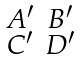<formula> <loc_0><loc_0><loc_500><loc_500>\begin{smallmatrix} A ^ { \prime } & B ^ { \prime } \\ C ^ { \prime } & D ^ { \prime } \end{smallmatrix}</formula> 